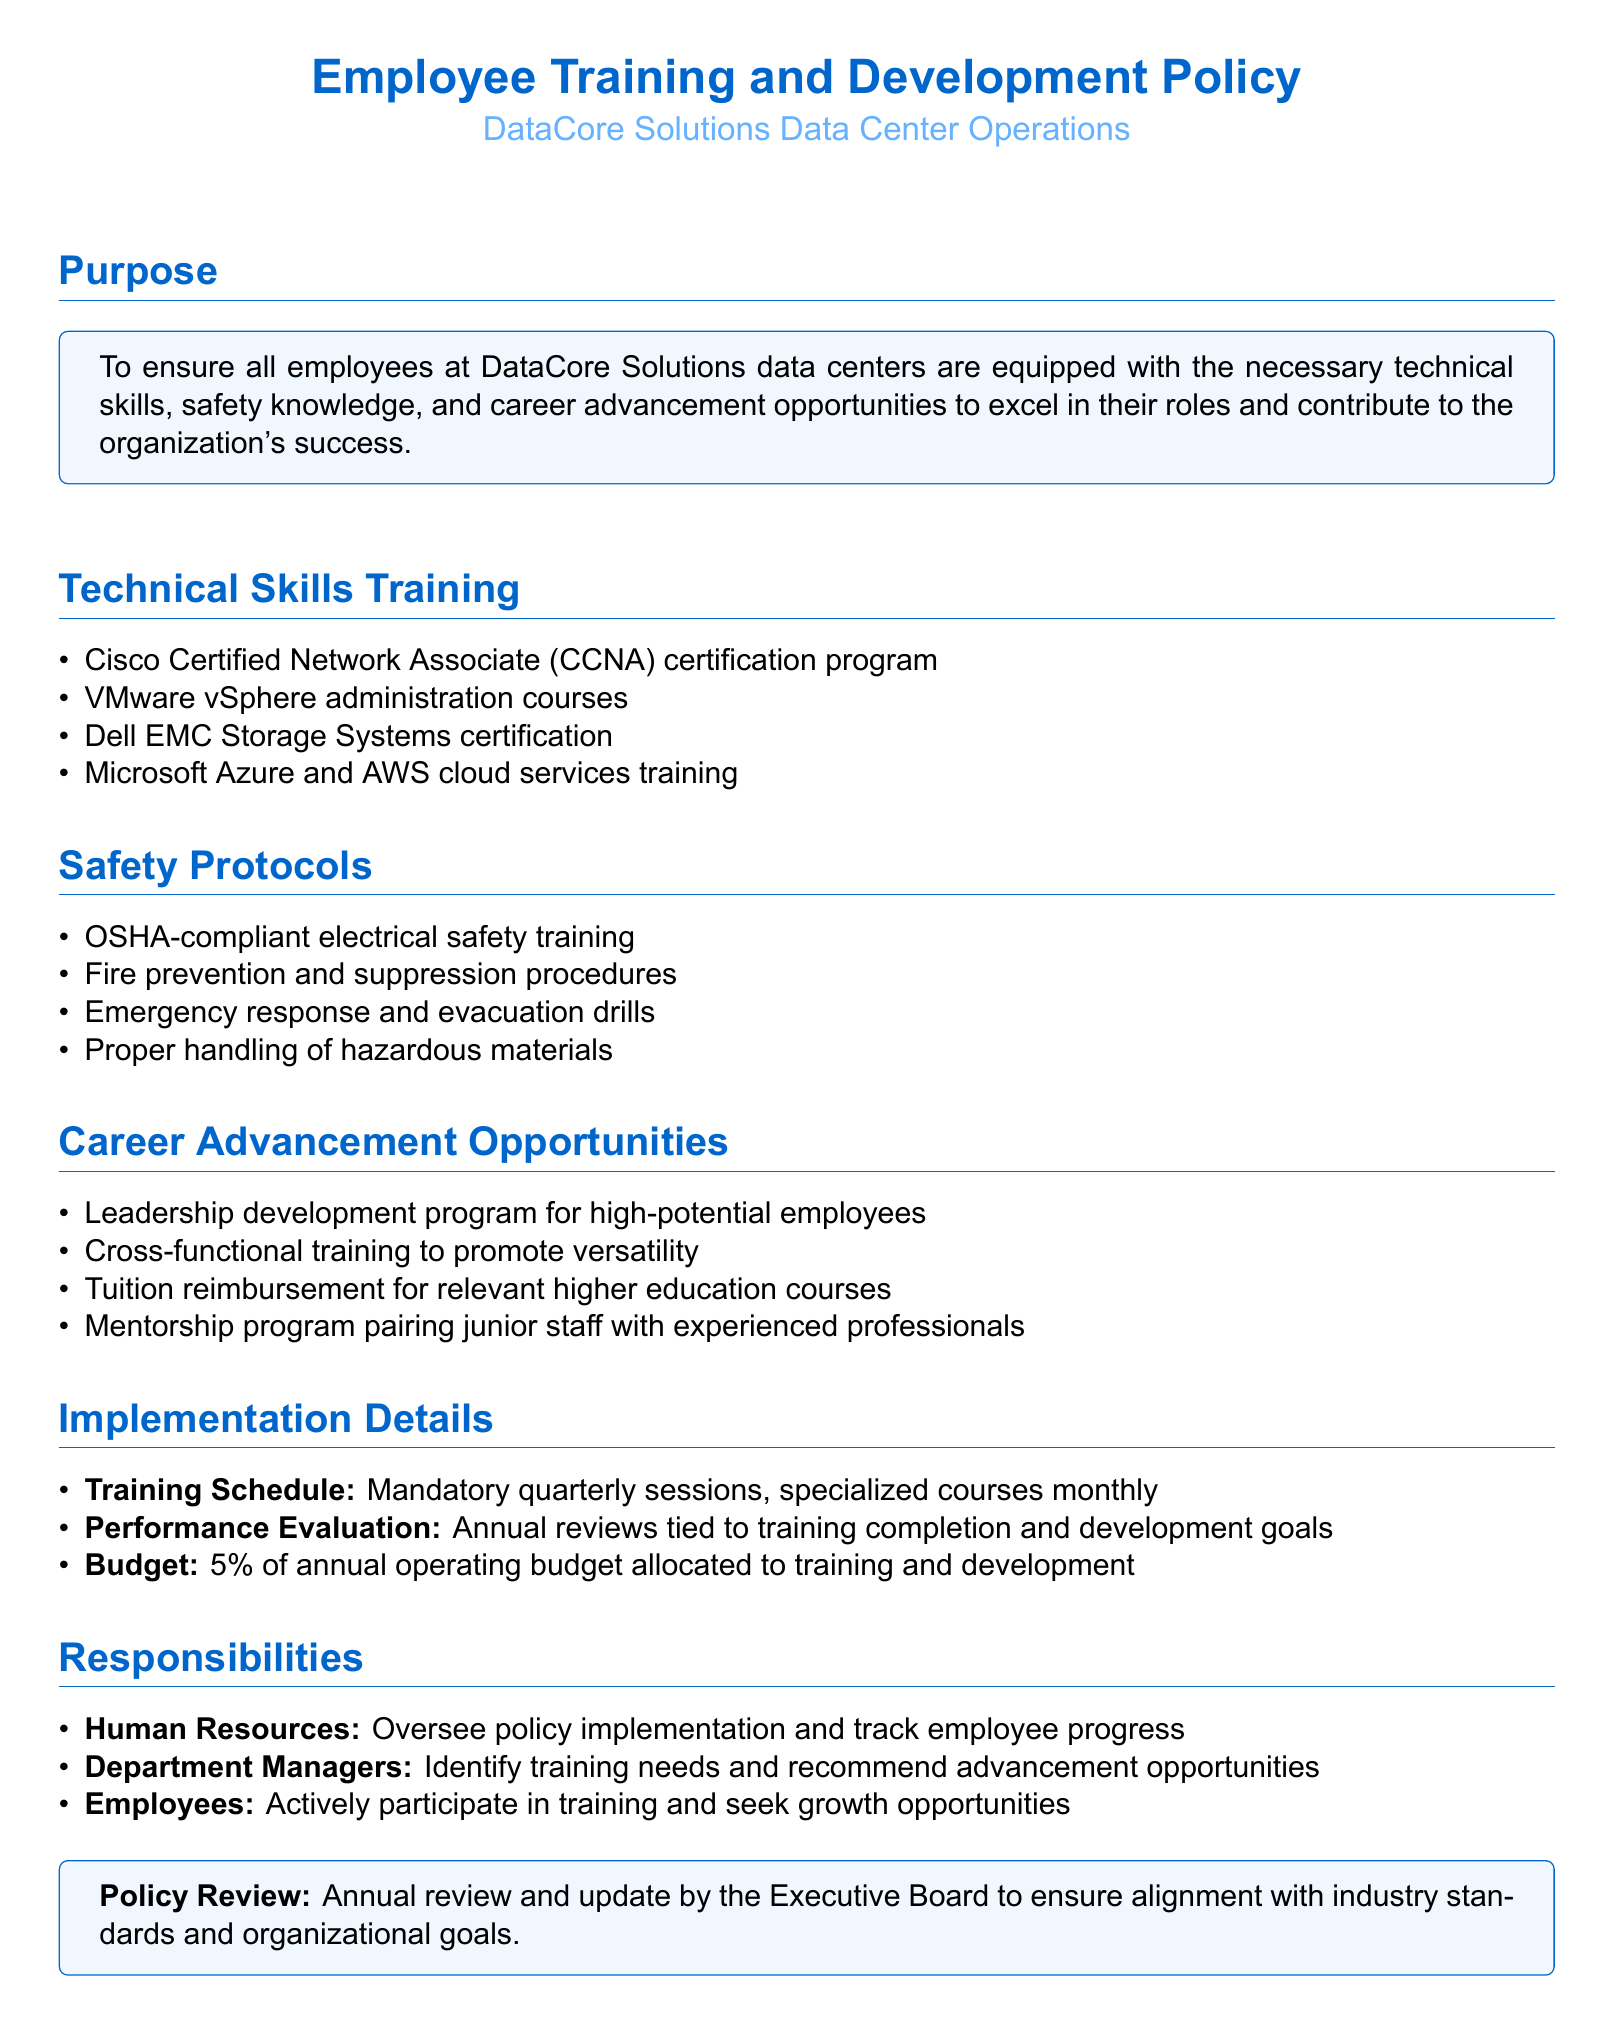What is the main purpose of the policy? The purpose serves as an introduction to the document, explaining its intent to provide training and opportunities for employees.
Answer: To ensure all employees at DataCore Solutions data centers are equipped with the necessary technical skills, safety knowledge, and career advancement opportunities to excel in their roles and contribute to the organization's success What certification program is mentioned for technical skills training? This certification program is listed under the technical skills training section of the document.
Answer: Cisco Certified Network Associate (CCNA) certification program How often are mandatory training sessions scheduled? The frequency of mandatory training sessions is stated in the implementation details section of the document.
Answer: Quarterly What type of drills are included in safety protocols? The safety drills are specifically mentioned to ensure employee preparedness for emergency situations.
Answer: Emergency response and evacuation drills What percentage of the annual operating budget is allocated to training? This percentage is specified in the implementation details section regarding budget allocation for training and development.
Answer: 5% Which department is responsible for overseeing policy implementation? The responsible party for overseeing the policy is noted in the responsibilities section of the document.
Answer: Human Resources What program is designed for high-potential employees? The specific program aimed at leadership development for progressing employees is named in the career advancement opportunities section.
Answer: Leadership development program Who pairs junior staff with experienced professionals? This role is described in the responsibilities section related to employee development and mentorship.
Answer: Mentorship program 